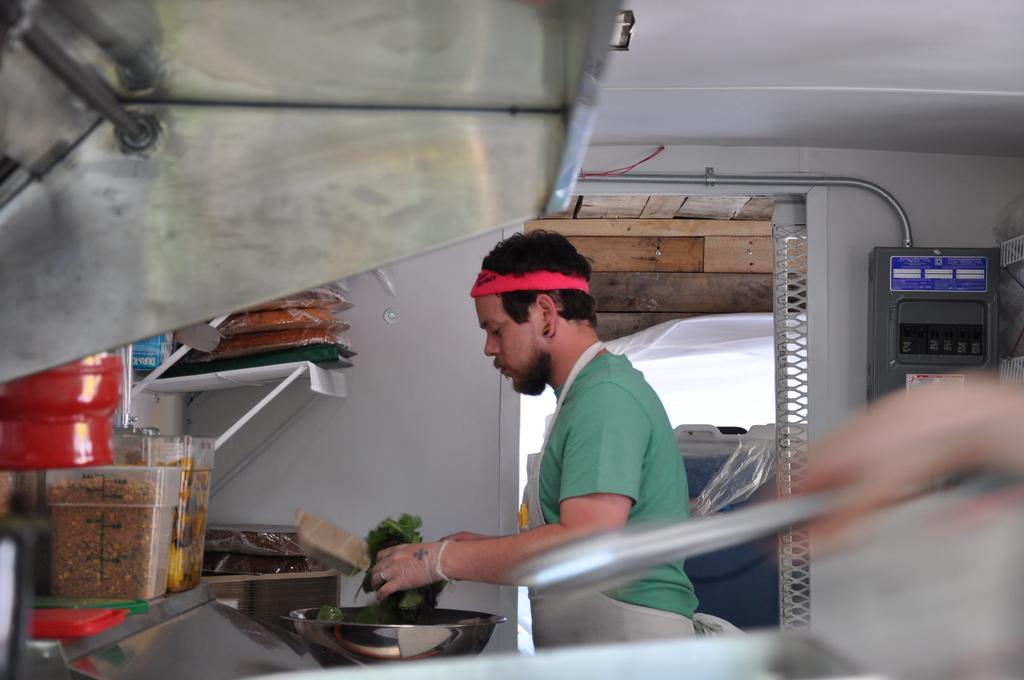Please provide a concise description of this image. In this picture we can see a person holding green vegetables in his hands. We can see a bowl, few boxes and food packets in the shelves. There is some food in these boxes. We can see a device. 